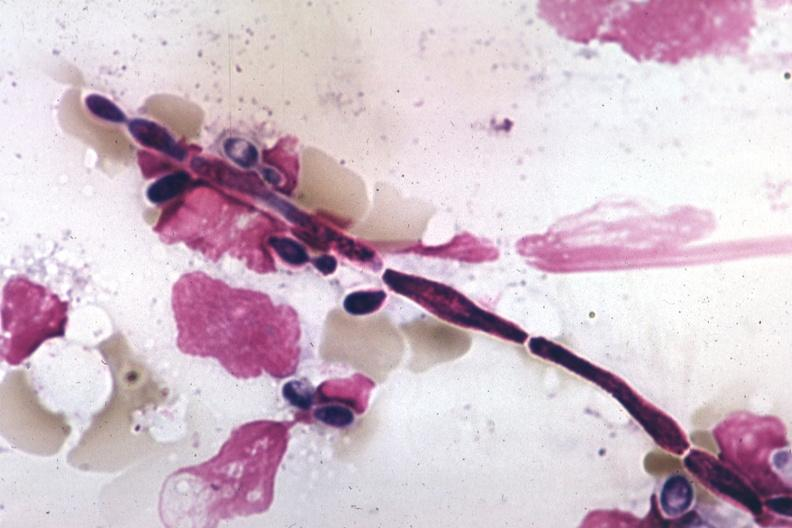s hematologic present?
Answer the question using a single word or phrase. Yes 